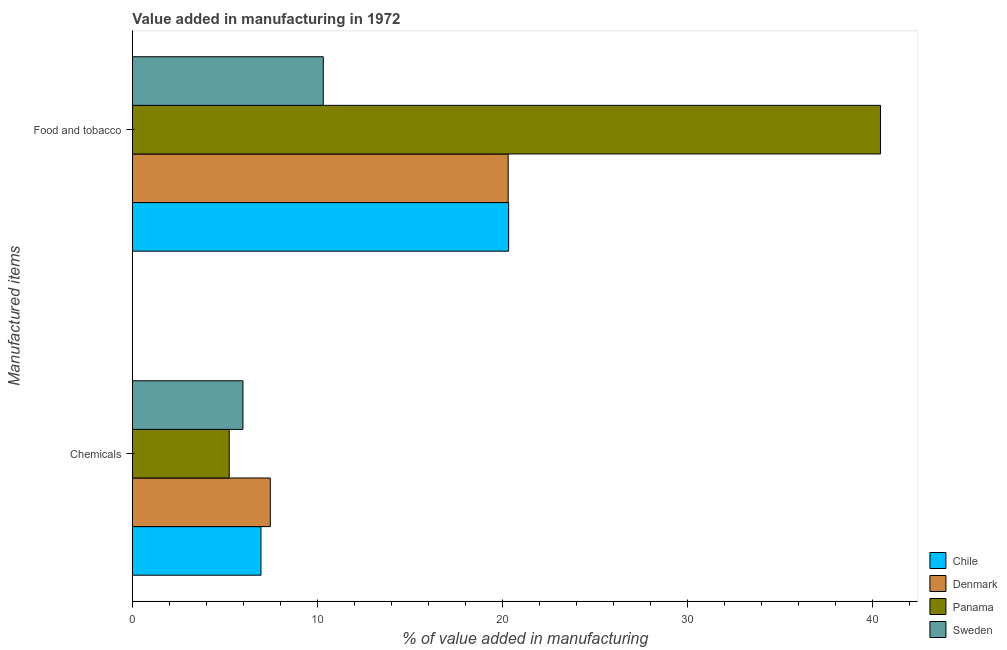How many different coloured bars are there?
Your answer should be compact. 4. What is the label of the 2nd group of bars from the top?
Your answer should be compact. Chemicals. What is the value added by  manufacturing chemicals in Chile?
Ensure brevity in your answer.  6.95. Across all countries, what is the maximum value added by manufacturing food and tobacco?
Offer a terse response. 40.45. Across all countries, what is the minimum value added by  manufacturing chemicals?
Give a very brief answer. 5.23. What is the total value added by manufacturing food and tobacco in the graph?
Provide a short and direct response. 91.42. What is the difference between the value added by manufacturing food and tobacco in Denmark and that in Chile?
Provide a short and direct response. -0.03. What is the difference between the value added by  manufacturing chemicals in Chile and the value added by manufacturing food and tobacco in Denmark?
Your answer should be compact. -13.37. What is the average value added by  manufacturing chemicals per country?
Make the answer very short. 6.4. What is the difference between the value added by  manufacturing chemicals and value added by manufacturing food and tobacco in Panama?
Offer a terse response. -35.22. What is the ratio of the value added by  manufacturing chemicals in Panama to that in Sweden?
Provide a succinct answer. 0.88. What does the 3rd bar from the top in Chemicals represents?
Ensure brevity in your answer.  Denmark. What does the 4th bar from the bottom in Food and tobacco represents?
Your answer should be compact. Sweden. Does the graph contain grids?
Provide a succinct answer. No. What is the title of the graph?
Provide a short and direct response. Value added in manufacturing in 1972. What is the label or title of the X-axis?
Offer a very short reply. % of value added in manufacturing. What is the label or title of the Y-axis?
Your response must be concise. Manufactured items. What is the % of value added in manufacturing of Chile in Chemicals?
Offer a terse response. 6.95. What is the % of value added in manufacturing in Denmark in Chemicals?
Your answer should be very brief. 7.45. What is the % of value added in manufacturing of Panama in Chemicals?
Provide a succinct answer. 5.23. What is the % of value added in manufacturing of Sweden in Chemicals?
Keep it short and to the point. 5.98. What is the % of value added in manufacturing of Chile in Food and tobacco?
Keep it short and to the point. 20.34. What is the % of value added in manufacturing of Denmark in Food and tobacco?
Your response must be concise. 20.32. What is the % of value added in manufacturing in Panama in Food and tobacco?
Provide a short and direct response. 40.45. What is the % of value added in manufacturing of Sweden in Food and tobacco?
Provide a short and direct response. 10.32. Across all Manufactured items, what is the maximum % of value added in manufacturing of Chile?
Your answer should be very brief. 20.34. Across all Manufactured items, what is the maximum % of value added in manufacturing in Denmark?
Your answer should be very brief. 20.32. Across all Manufactured items, what is the maximum % of value added in manufacturing of Panama?
Your answer should be very brief. 40.45. Across all Manufactured items, what is the maximum % of value added in manufacturing of Sweden?
Provide a succinct answer. 10.32. Across all Manufactured items, what is the minimum % of value added in manufacturing of Chile?
Your response must be concise. 6.95. Across all Manufactured items, what is the minimum % of value added in manufacturing in Denmark?
Offer a very short reply. 7.45. Across all Manufactured items, what is the minimum % of value added in manufacturing of Panama?
Make the answer very short. 5.23. Across all Manufactured items, what is the minimum % of value added in manufacturing of Sweden?
Keep it short and to the point. 5.98. What is the total % of value added in manufacturing in Chile in the graph?
Offer a very short reply. 27.29. What is the total % of value added in manufacturing in Denmark in the graph?
Your response must be concise. 27.77. What is the total % of value added in manufacturing in Panama in the graph?
Give a very brief answer. 45.68. What is the total % of value added in manufacturing of Sweden in the graph?
Ensure brevity in your answer.  16.29. What is the difference between the % of value added in manufacturing in Chile in Chemicals and that in Food and tobacco?
Offer a very short reply. -13.39. What is the difference between the % of value added in manufacturing in Denmark in Chemicals and that in Food and tobacco?
Offer a terse response. -12.86. What is the difference between the % of value added in manufacturing in Panama in Chemicals and that in Food and tobacco?
Keep it short and to the point. -35.22. What is the difference between the % of value added in manufacturing of Sweden in Chemicals and that in Food and tobacco?
Your answer should be very brief. -4.34. What is the difference between the % of value added in manufacturing of Chile in Chemicals and the % of value added in manufacturing of Denmark in Food and tobacco?
Provide a short and direct response. -13.37. What is the difference between the % of value added in manufacturing of Chile in Chemicals and the % of value added in manufacturing of Panama in Food and tobacco?
Offer a terse response. -33.5. What is the difference between the % of value added in manufacturing in Chile in Chemicals and the % of value added in manufacturing in Sweden in Food and tobacco?
Provide a succinct answer. -3.37. What is the difference between the % of value added in manufacturing in Denmark in Chemicals and the % of value added in manufacturing in Panama in Food and tobacco?
Ensure brevity in your answer.  -32.99. What is the difference between the % of value added in manufacturing of Denmark in Chemicals and the % of value added in manufacturing of Sweden in Food and tobacco?
Ensure brevity in your answer.  -2.86. What is the difference between the % of value added in manufacturing of Panama in Chemicals and the % of value added in manufacturing of Sweden in Food and tobacco?
Make the answer very short. -5.09. What is the average % of value added in manufacturing in Chile per Manufactured items?
Keep it short and to the point. 13.65. What is the average % of value added in manufacturing of Denmark per Manufactured items?
Provide a short and direct response. 13.89. What is the average % of value added in manufacturing in Panama per Manufactured items?
Offer a very short reply. 22.84. What is the average % of value added in manufacturing in Sweden per Manufactured items?
Your answer should be very brief. 8.15. What is the difference between the % of value added in manufacturing of Chile and % of value added in manufacturing of Denmark in Chemicals?
Give a very brief answer. -0.5. What is the difference between the % of value added in manufacturing in Chile and % of value added in manufacturing in Panama in Chemicals?
Offer a terse response. 1.72. What is the difference between the % of value added in manufacturing in Chile and % of value added in manufacturing in Sweden in Chemicals?
Ensure brevity in your answer.  0.98. What is the difference between the % of value added in manufacturing in Denmark and % of value added in manufacturing in Panama in Chemicals?
Offer a very short reply. 2.22. What is the difference between the % of value added in manufacturing in Denmark and % of value added in manufacturing in Sweden in Chemicals?
Make the answer very short. 1.48. What is the difference between the % of value added in manufacturing in Panama and % of value added in manufacturing in Sweden in Chemicals?
Give a very brief answer. -0.74. What is the difference between the % of value added in manufacturing of Chile and % of value added in manufacturing of Denmark in Food and tobacco?
Your response must be concise. 0.03. What is the difference between the % of value added in manufacturing in Chile and % of value added in manufacturing in Panama in Food and tobacco?
Offer a terse response. -20.11. What is the difference between the % of value added in manufacturing in Chile and % of value added in manufacturing in Sweden in Food and tobacco?
Ensure brevity in your answer.  10.02. What is the difference between the % of value added in manufacturing in Denmark and % of value added in manufacturing in Panama in Food and tobacco?
Keep it short and to the point. -20.13. What is the difference between the % of value added in manufacturing of Denmark and % of value added in manufacturing of Sweden in Food and tobacco?
Give a very brief answer. 10. What is the difference between the % of value added in manufacturing in Panama and % of value added in manufacturing in Sweden in Food and tobacco?
Ensure brevity in your answer.  30.13. What is the ratio of the % of value added in manufacturing of Chile in Chemicals to that in Food and tobacco?
Give a very brief answer. 0.34. What is the ratio of the % of value added in manufacturing of Denmark in Chemicals to that in Food and tobacco?
Give a very brief answer. 0.37. What is the ratio of the % of value added in manufacturing in Panama in Chemicals to that in Food and tobacco?
Your answer should be compact. 0.13. What is the ratio of the % of value added in manufacturing in Sweden in Chemicals to that in Food and tobacco?
Keep it short and to the point. 0.58. What is the difference between the highest and the second highest % of value added in manufacturing in Chile?
Keep it short and to the point. 13.39. What is the difference between the highest and the second highest % of value added in manufacturing in Denmark?
Keep it short and to the point. 12.86. What is the difference between the highest and the second highest % of value added in manufacturing in Panama?
Your answer should be compact. 35.22. What is the difference between the highest and the second highest % of value added in manufacturing in Sweden?
Your response must be concise. 4.34. What is the difference between the highest and the lowest % of value added in manufacturing of Chile?
Give a very brief answer. 13.39. What is the difference between the highest and the lowest % of value added in manufacturing in Denmark?
Offer a terse response. 12.86. What is the difference between the highest and the lowest % of value added in manufacturing of Panama?
Give a very brief answer. 35.22. What is the difference between the highest and the lowest % of value added in manufacturing of Sweden?
Provide a short and direct response. 4.34. 